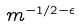Convert formula to latex. <formula><loc_0><loc_0><loc_500><loc_500>m ^ { - 1 / 2 - \epsilon }</formula> 